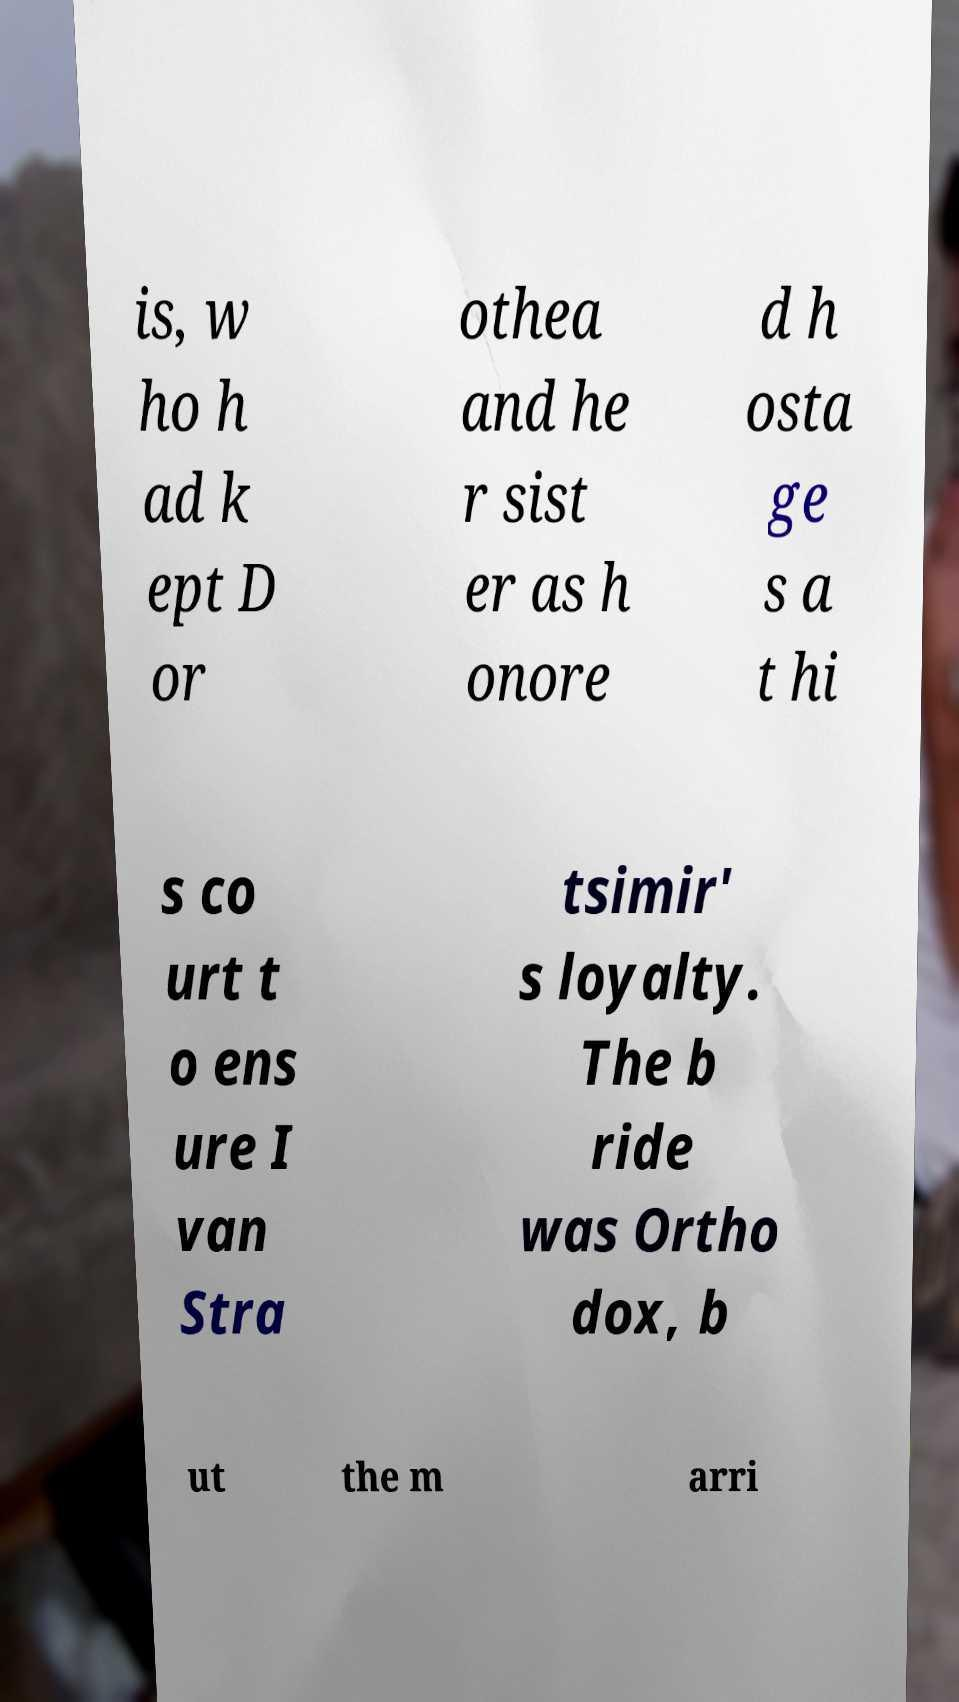Could you assist in decoding the text presented in this image and type it out clearly? is, w ho h ad k ept D or othea and he r sist er as h onore d h osta ge s a t hi s co urt t o ens ure I van Stra tsimir' s loyalty. The b ride was Ortho dox, b ut the m arri 